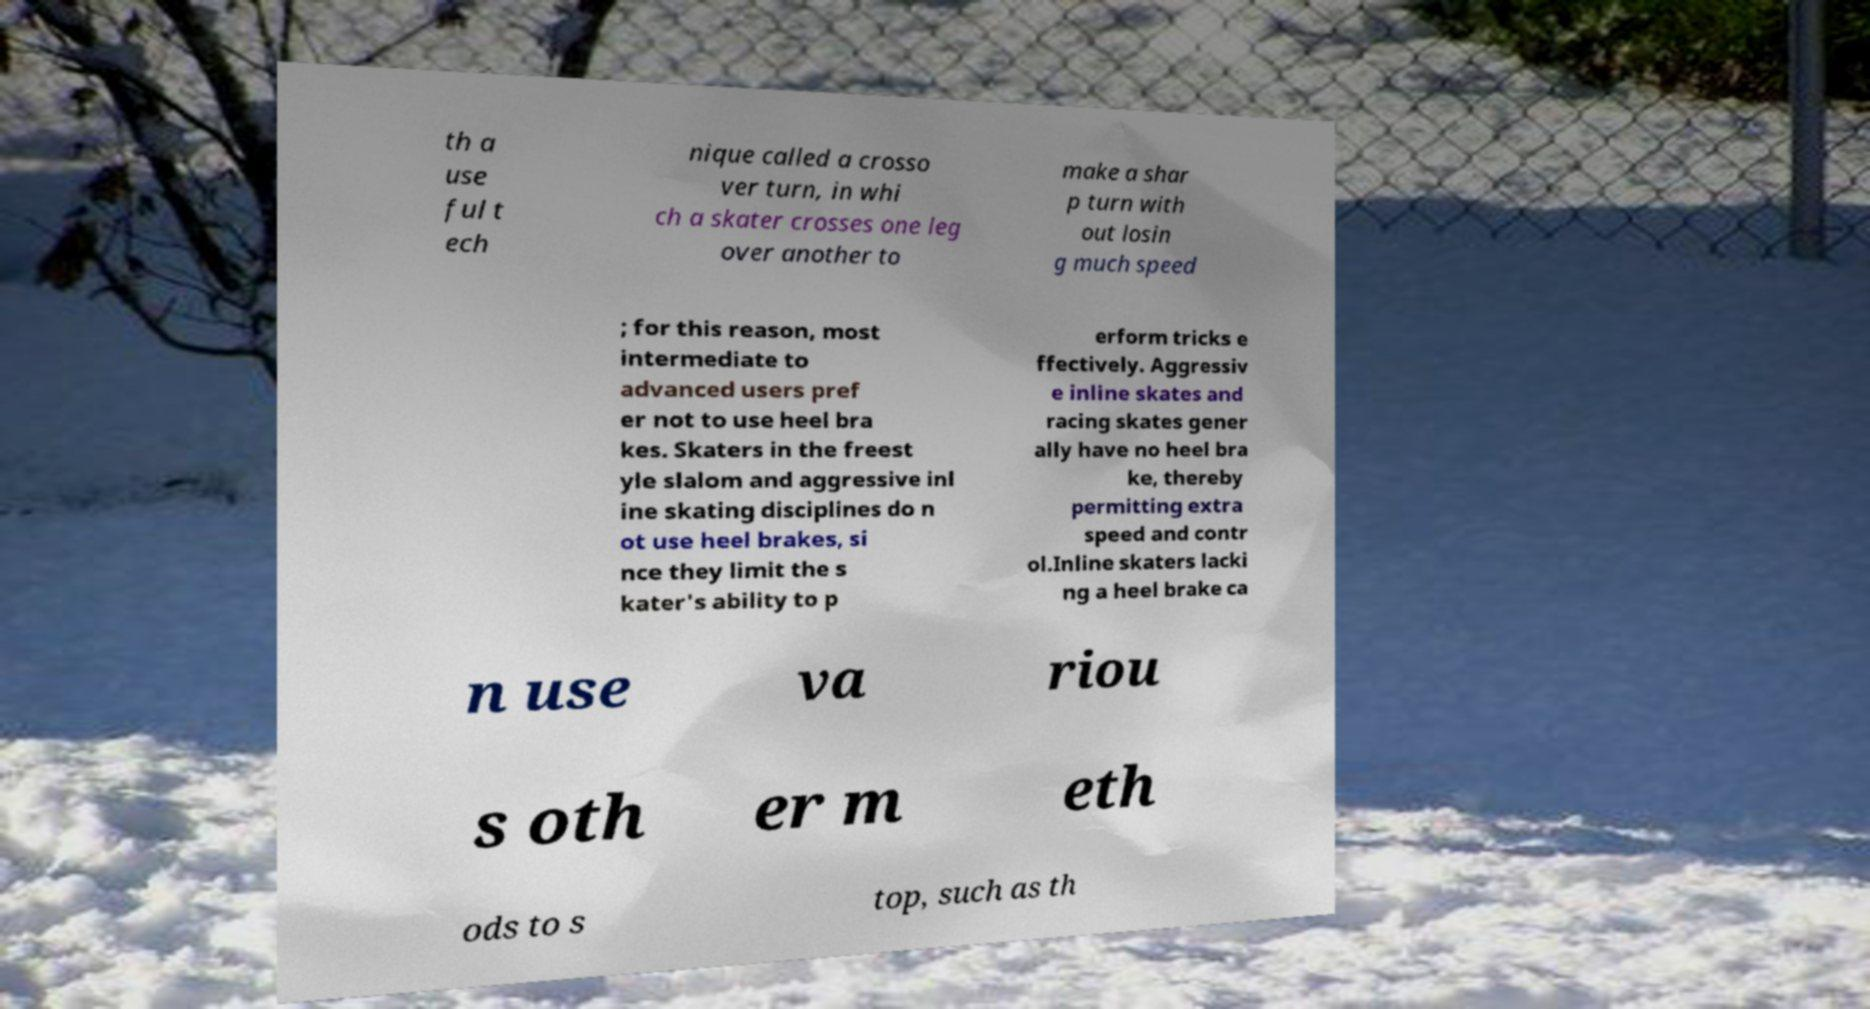Can you read and provide the text displayed in the image?This photo seems to have some interesting text. Can you extract and type it out for me? th a use ful t ech nique called a crosso ver turn, in whi ch a skater crosses one leg over another to make a shar p turn with out losin g much speed ; for this reason, most intermediate to advanced users pref er not to use heel bra kes. Skaters in the freest yle slalom and aggressive inl ine skating disciplines do n ot use heel brakes, si nce they limit the s kater's ability to p erform tricks e ffectively. Aggressiv e inline skates and racing skates gener ally have no heel bra ke, thereby permitting extra speed and contr ol.Inline skaters lacki ng a heel brake ca n use va riou s oth er m eth ods to s top, such as th 